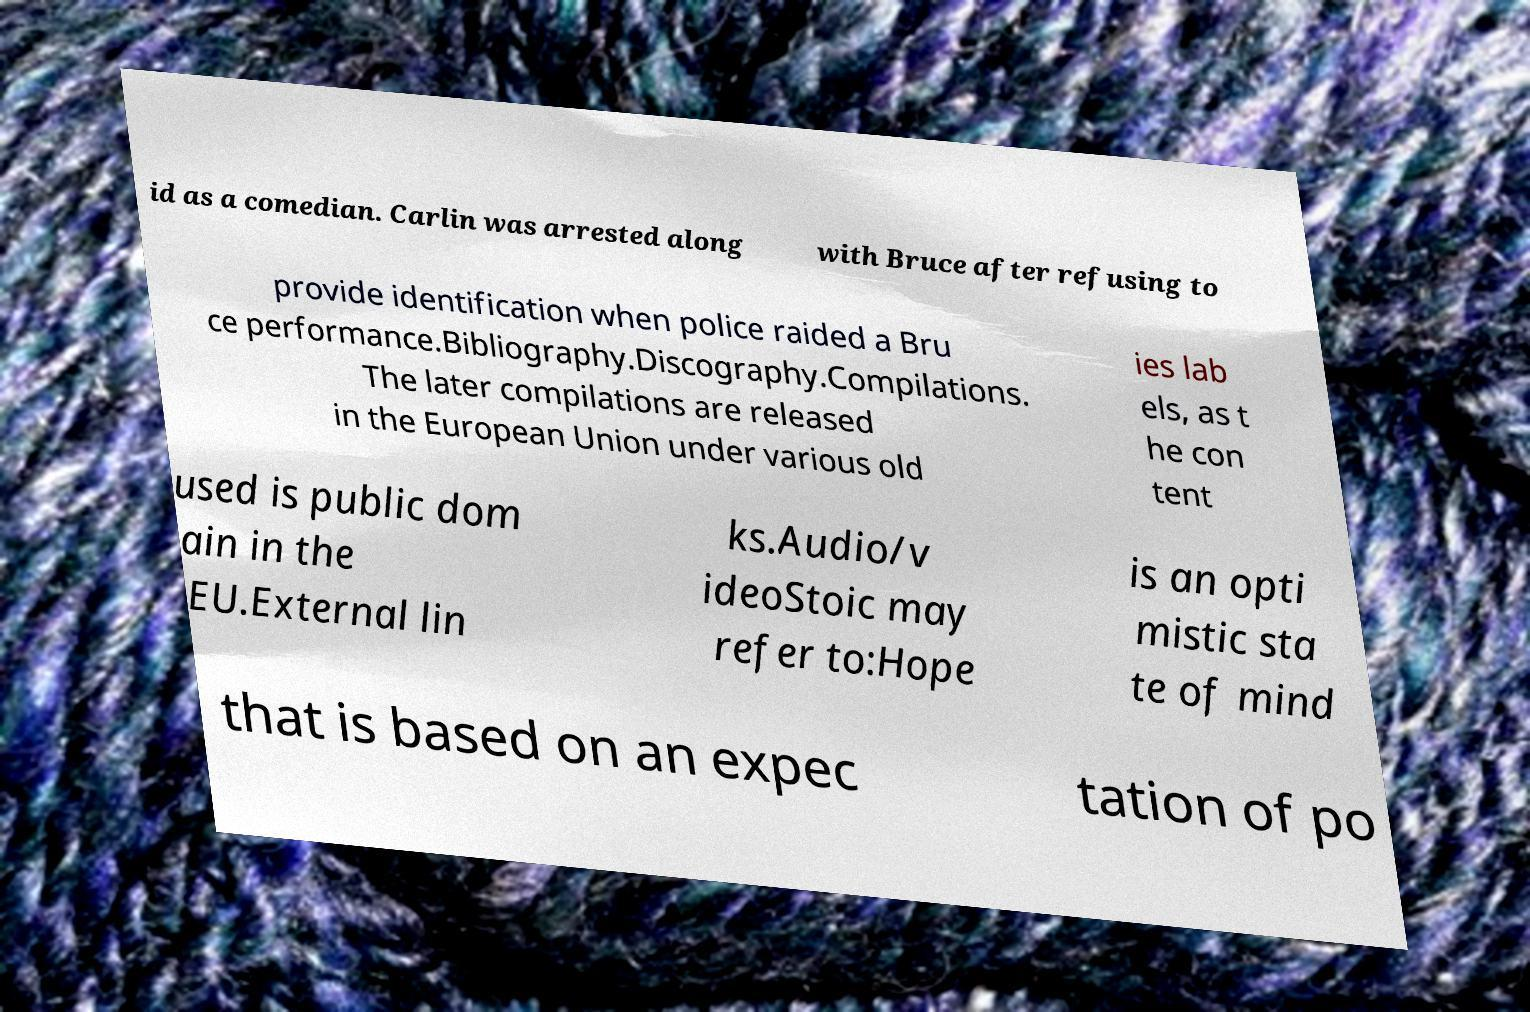Can you accurately transcribe the text from the provided image for me? id as a comedian. Carlin was arrested along with Bruce after refusing to provide identification when police raided a Bru ce performance.Bibliography.Discography.Compilations. The later compilations are released in the European Union under various old ies lab els, as t he con tent used is public dom ain in the EU.External lin ks.Audio/v ideoStoic may refer to:Hope is an opti mistic sta te of mind that is based on an expec tation of po 